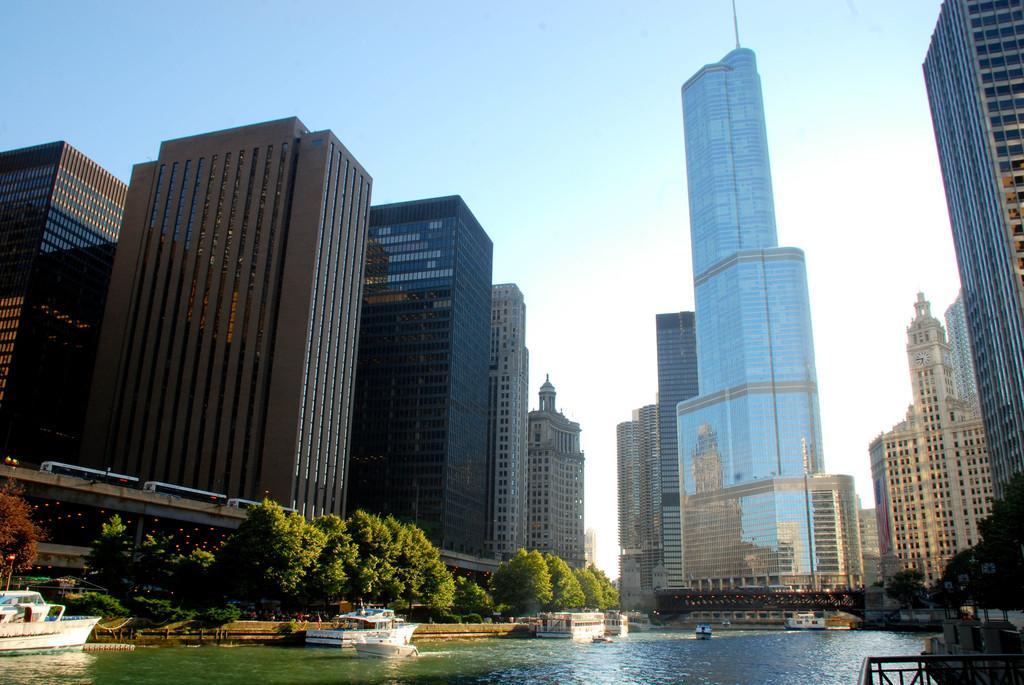In one or two sentences, can you explain what this image depicts? This picture might be taken from outside of the building. In this image, on the left side, we can see some ships which are drowning on the water, trees, bridge, on that bridge, we can see some vehicles, buildings. On the left side, we can also see some trees, metal rods, buildings. In the middle of the image, we can see some ships which are drowning on the water, buildings. At the top, we can see a sky, at the bottom, we can see a water in a lake. 